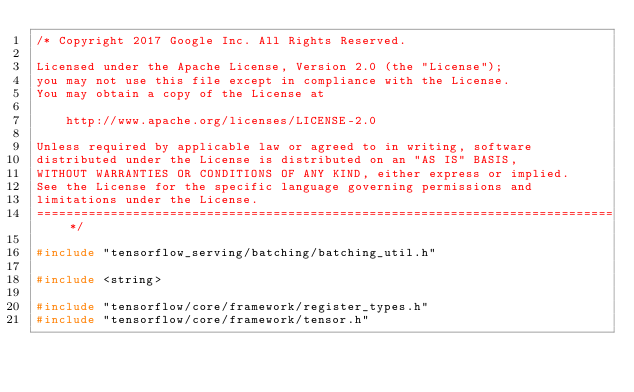Convert code to text. <code><loc_0><loc_0><loc_500><loc_500><_C++_>/* Copyright 2017 Google Inc. All Rights Reserved.

Licensed under the Apache License, Version 2.0 (the "License");
you may not use this file except in compliance with the License.
You may obtain a copy of the License at

    http://www.apache.org/licenses/LICENSE-2.0

Unless required by applicable law or agreed to in writing, software
distributed under the License is distributed on an "AS IS" BASIS,
WITHOUT WARRANTIES OR CONDITIONS OF ANY KIND, either express or implied.
See the License for the specific language governing permissions and
limitations under the License.
==============================================================================*/

#include "tensorflow_serving/batching/batching_util.h"

#include <string>

#include "tensorflow/core/framework/register_types.h"
#include "tensorflow/core/framework/tensor.h"</code> 